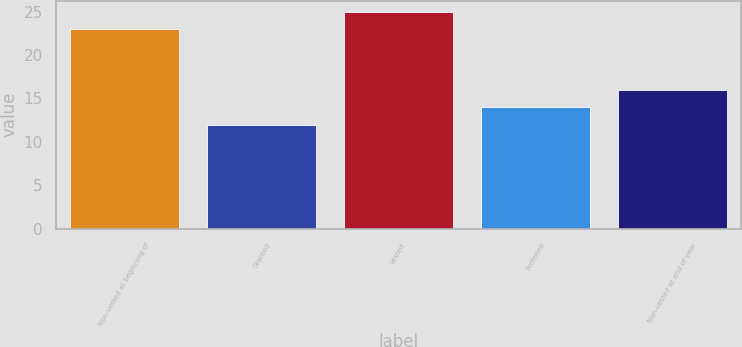<chart> <loc_0><loc_0><loc_500><loc_500><bar_chart><fcel>Non-vested at beginning of<fcel>Granted<fcel>Vested<fcel>Forfeited<fcel>Non-vested at end of year<nl><fcel>23<fcel>12<fcel>25<fcel>14<fcel>16<nl></chart> 